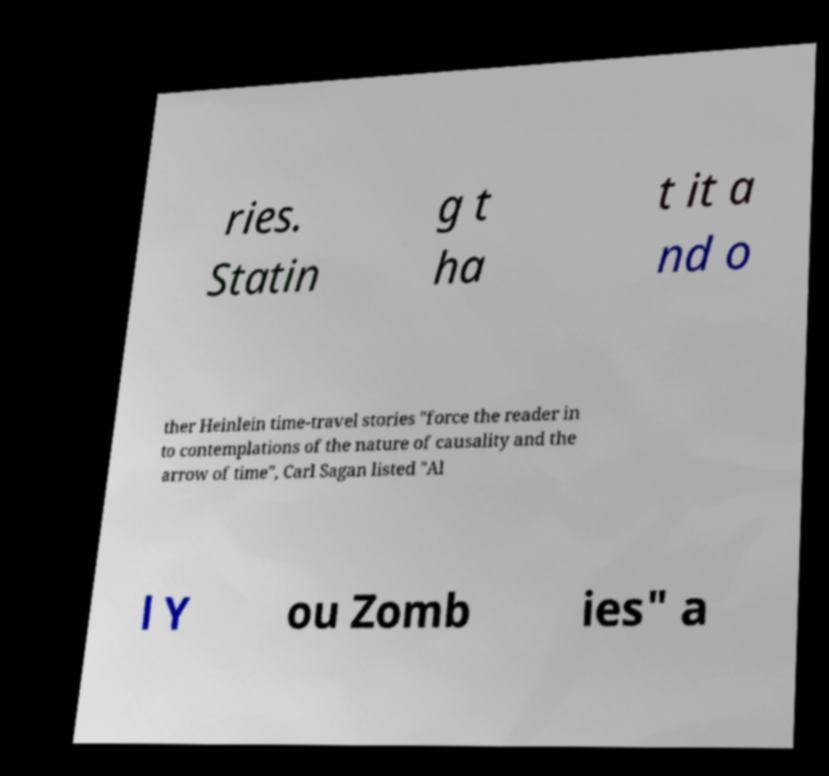Please read and relay the text visible in this image. What does it say? ries. Statin g t ha t it a nd o ther Heinlein time-travel stories "force the reader in to contemplations of the nature of causality and the arrow of time", Carl Sagan listed "Al l Y ou Zomb ies" a 